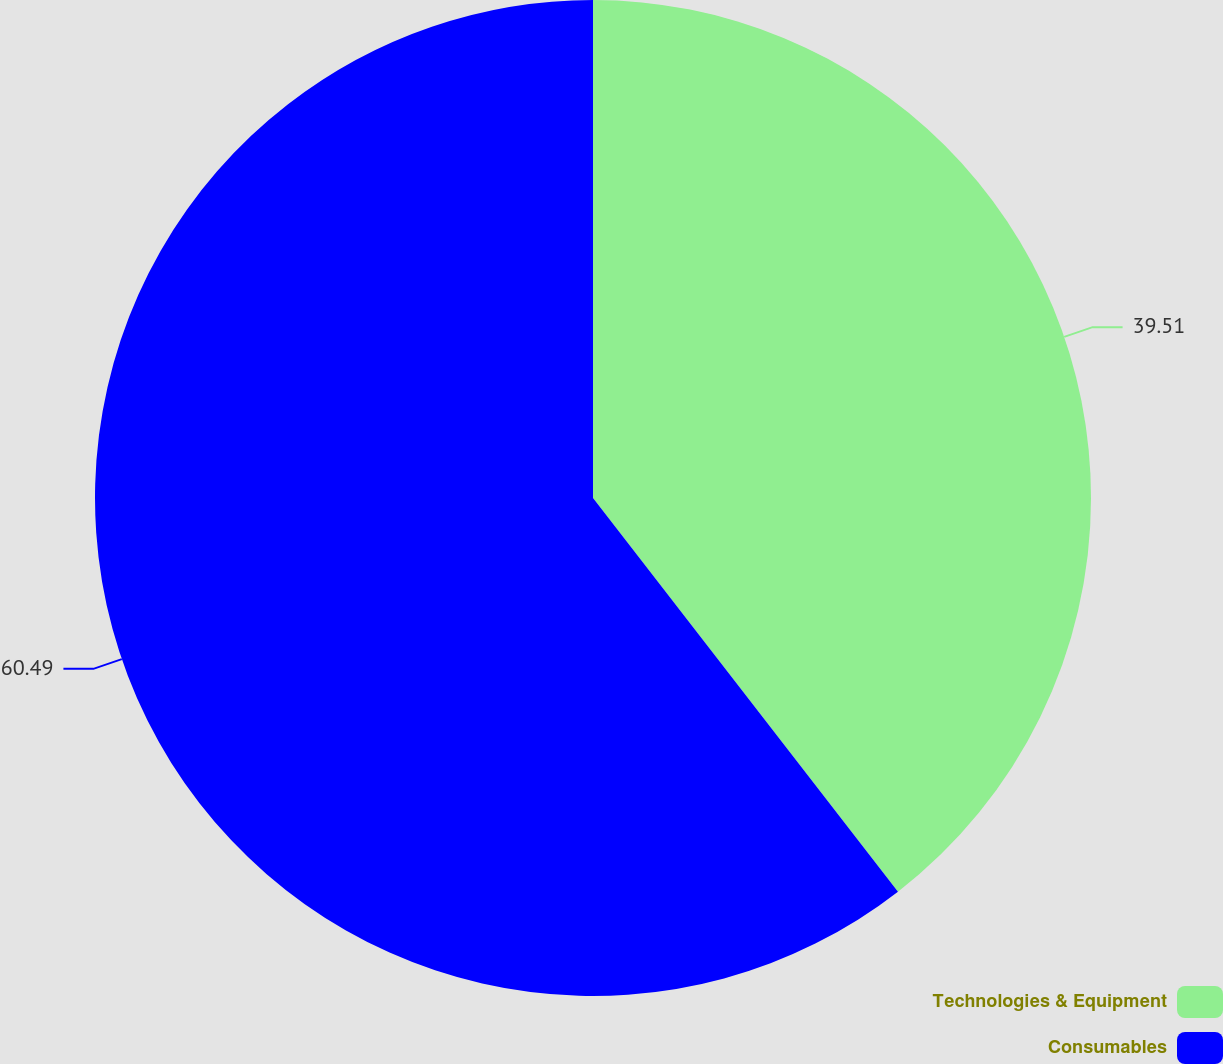<chart> <loc_0><loc_0><loc_500><loc_500><pie_chart><fcel>Technologies & Equipment<fcel>Consumables<nl><fcel>39.51%<fcel>60.49%<nl></chart> 